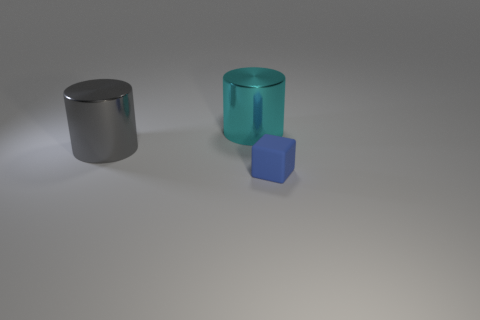Add 2 large cyan cylinders. How many objects exist? 5 Subtract all gray cylinders. How many cylinders are left? 1 Subtract all blocks. How many objects are left? 2 Subtract 1 cubes. How many cubes are left? 0 Subtract all red rubber blocks. Subtract all big cyan cylinders. How many objects are left? 2 Add 1 large gray shiny things. How many large gray shiny things are left? 2 Add 1 blue things. How many blue things exist? 2 Subtract 0 red balls. How many objects are left? 3 Subtract all brown cylinders. Subtract all gray spheres. How many cylinders are left? 2 